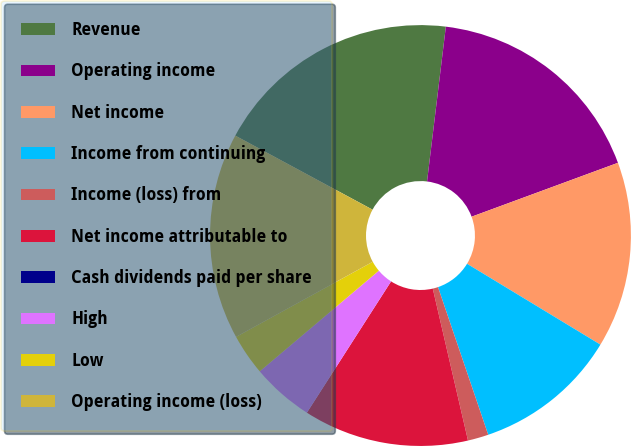Convert chart to OTSL. <chart><loc_0><loc_0><loc_500><loc_500><pie_chart><fcel>Revenue<fcel>Operating income<fcel>Net income<fcel>Income from continuing<fcel>Income (loss) from<fcel>Net income attributable to<fcel>Cash dividends paid per share<fcel>High<fcel>Low<fcel>Operating income (loss)<nl><fcel>19.05%<fcel>17.46%<fcel>14.29%<fcel>11.11%<fcel>1.59%<fcel>12.7%<fcel>0.0%<fcel>4.76%<fcel>3.17%<fcel>15.87%<nl></chart> 